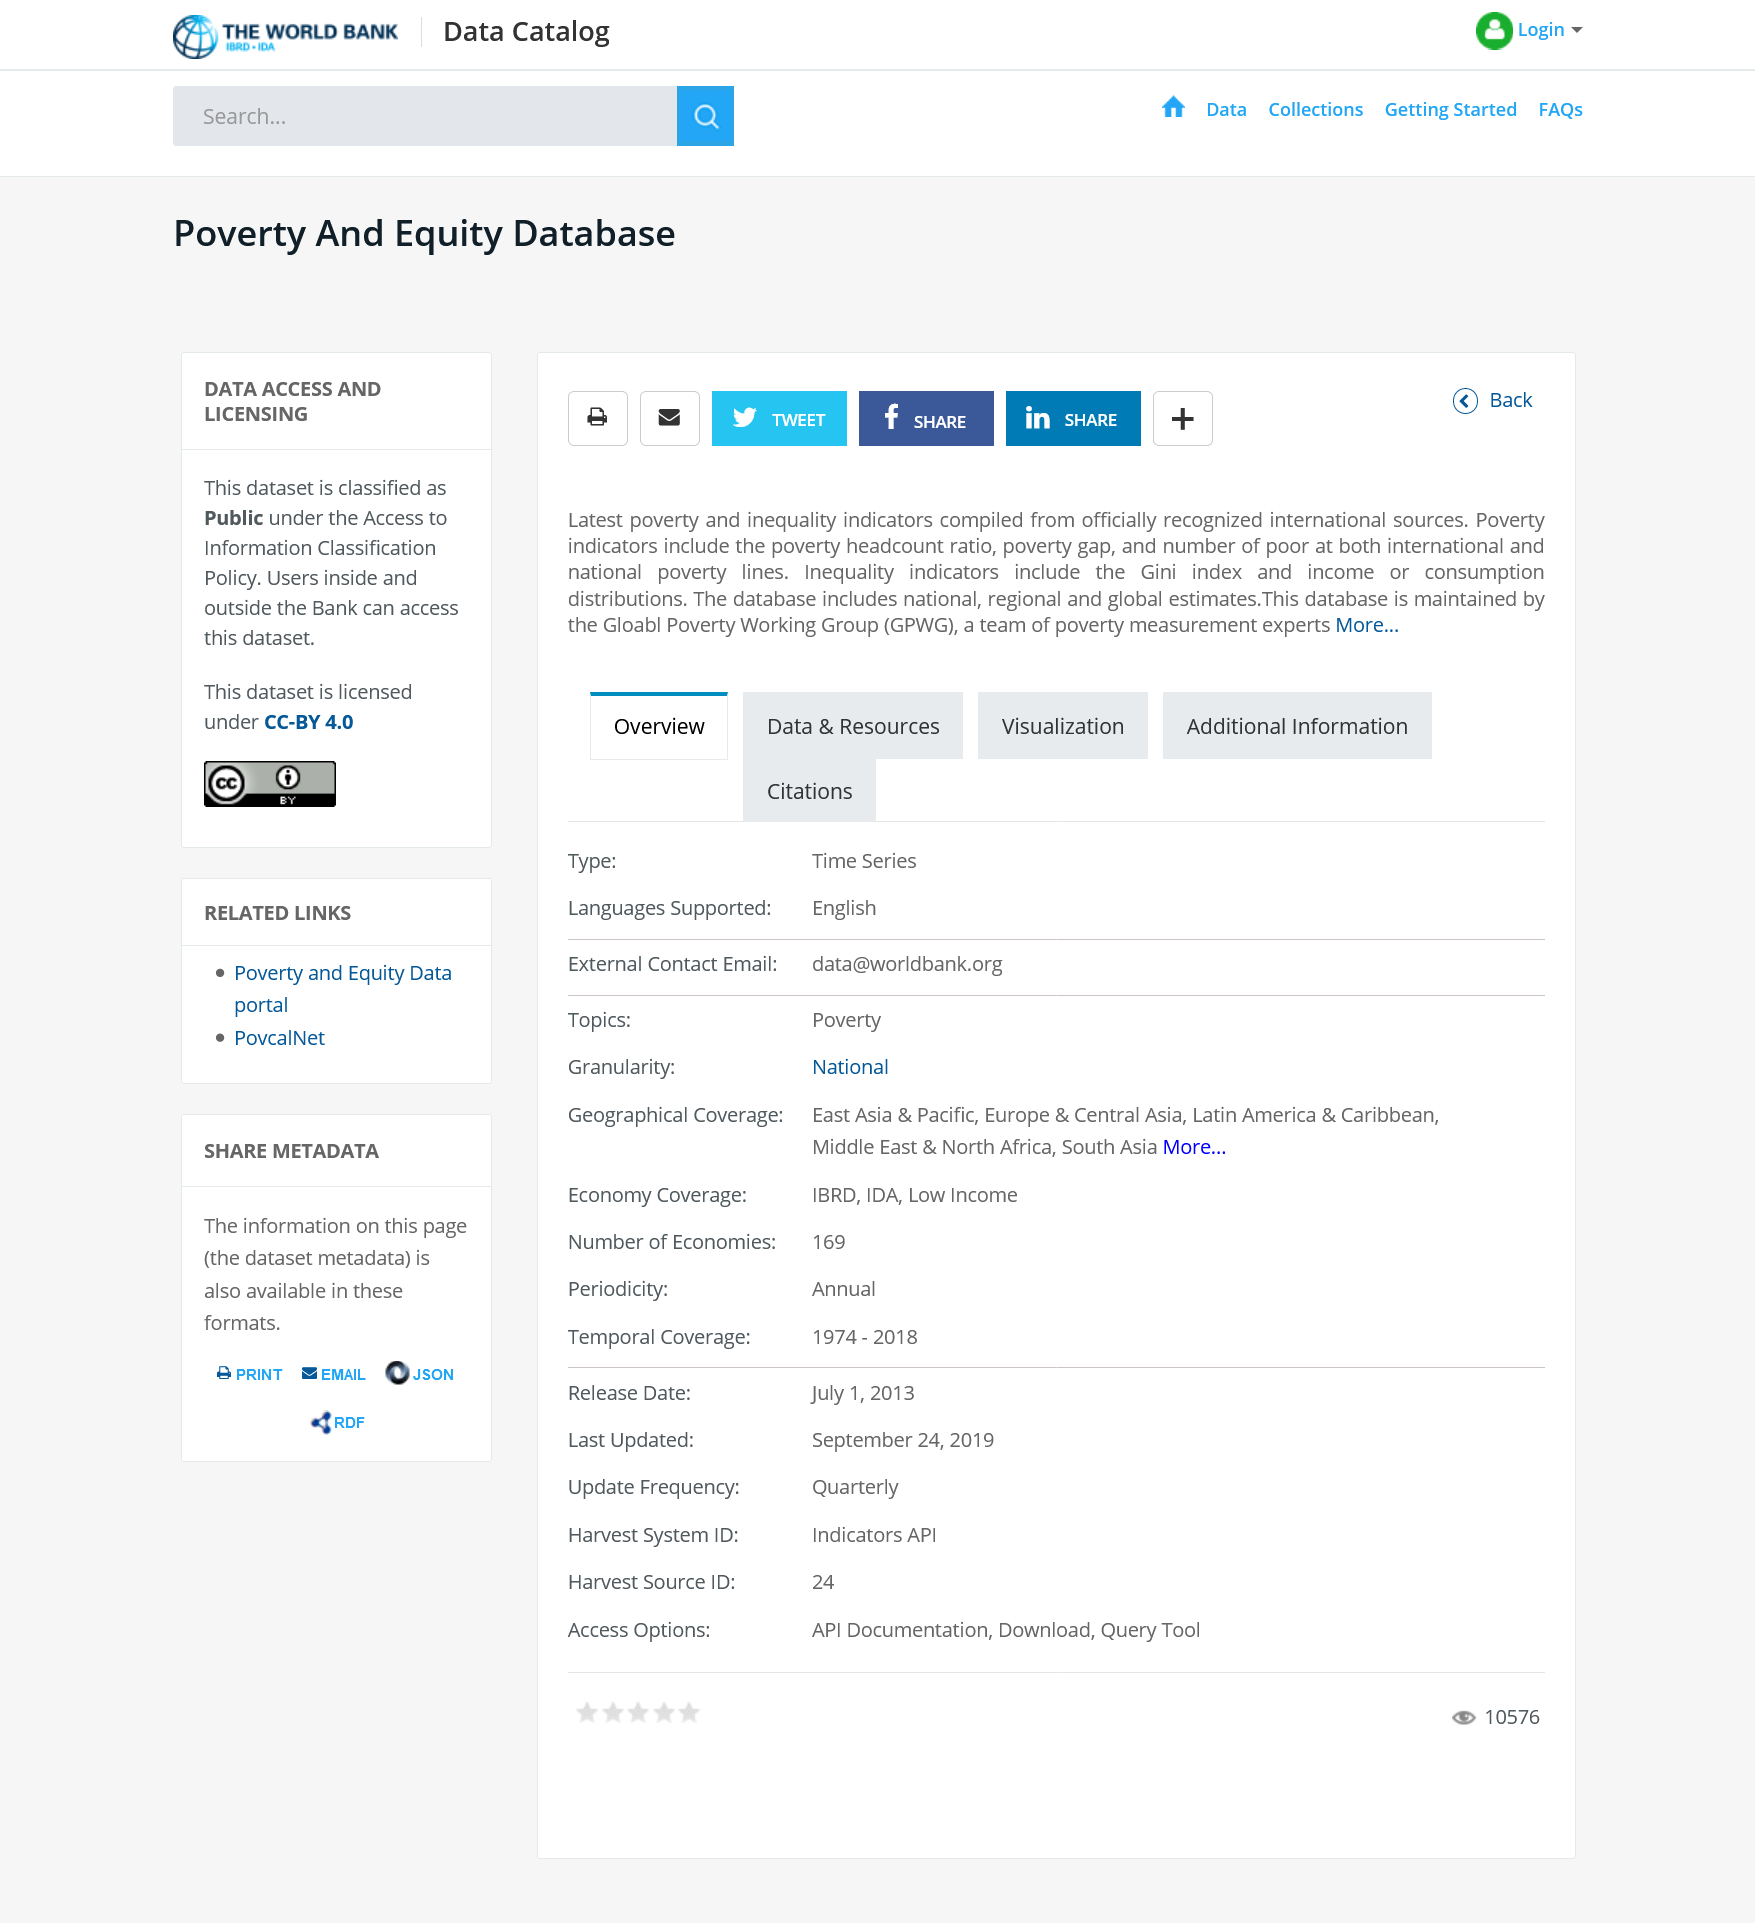Point out several critical features in this image. Some inequality indicators include the Gini index, which measures the distribution of income or consumption, and other indicators such as the Lorenz curve, the Palma ratio, and the Theil index. These indicators provide valuable insights into the degree of inequality in a given population or society. Poverty indicators are measurements used to assess the level of poverty in a community or society. These indicators can include the poverty headcount ratio, poverty gap, and the number of people living in poverty at both international and national poverty lines. Understanding these indicators is important for policymakers and stakeholders to develop effective strategies to combat poverty and promote economic development. The Global Poverty Working Group (GPWG) is responsible for maintaining this database. 